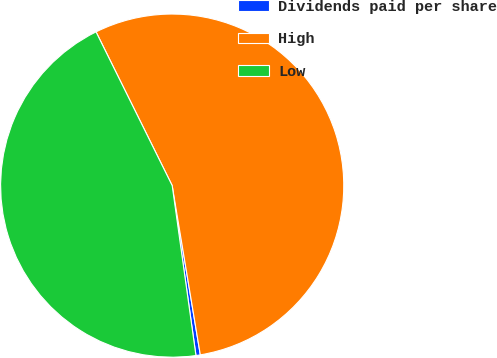<chart> <loc_0><loc_0><loc_500><loc_500><pie_chart><fcel>Dividends paid per share<fcel>High<fcel>Low<nl><fcel>0.41%<fcel>54.7%<fcel>44.89%<nl></chart> 